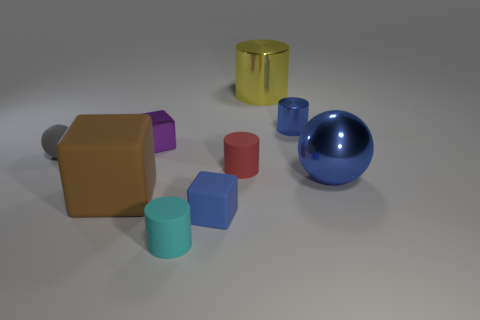Subtract all yellow cylinders. How many cylinders are left? 3 Subtract all large metal cylinders. How many cylinders are left? 3 Subtract all purple cylinders. Subtract all blue cubes. How many cylinders are left? 4 Add 1 green matte spheres. How many objects exist? 10 Subtract all cubes. How many objects are left? 6 Add 3 red matte cylinders. How many red matte cylinders are left? 4 Add 8 cyan cylinders. How many cyan cylinders exist? 9 Subtract 0 yellow blocks. How many objects are left? 9 Subtract all small cyan balls. Subtract all tiny red rubber things. How many objects are left? 8 